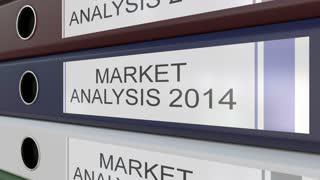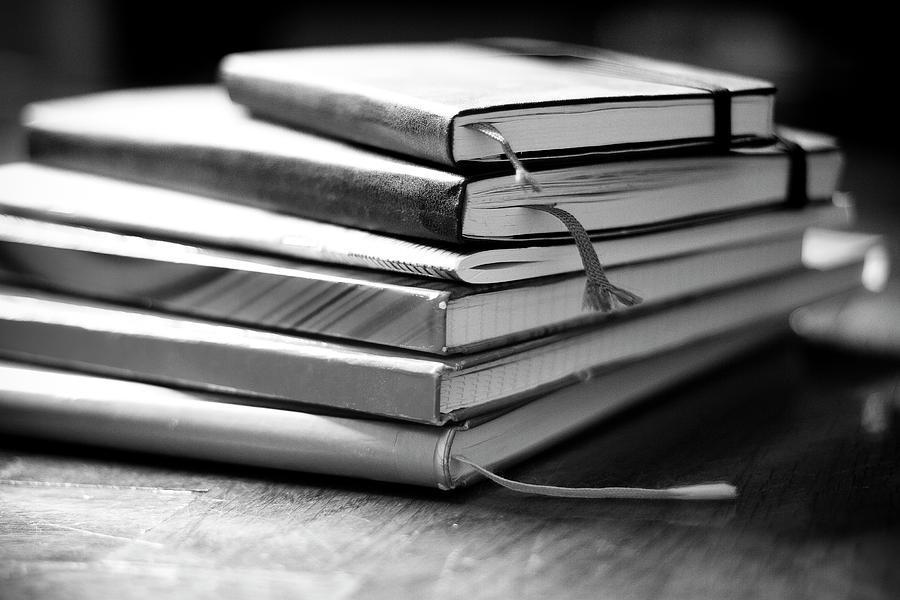The first image is the image on the left, the second image is the image on the right. For the images displayed, is the sentence "The left image has binders with visible labels." factually correct? Answer yes or no. Yes. The first image is the image on the left, the second image is the image on the right. Examine the images to the left and right. Is the description "An image shows the labeled ends of three stacked binders of different colors." accurate? Answer yes or no. Yes. 